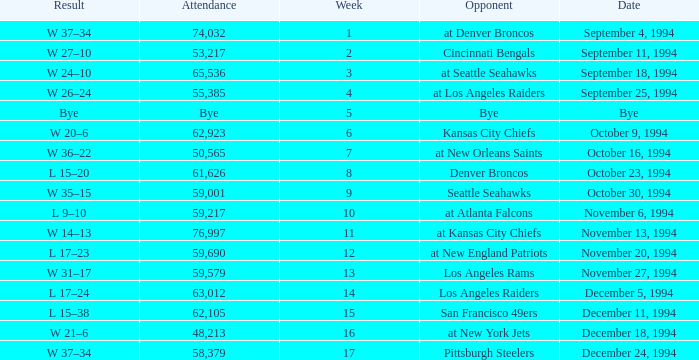On November 20, 1994, what was the result of the game? L 17–23. 